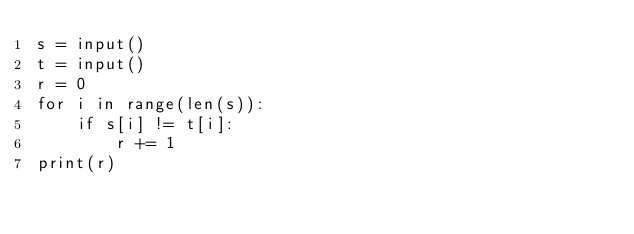<code> <loc_0><loc_0><loc_500><loc_500><_Python_>s = input()
t = input()
r = 0
for i in range(len(s)):
    if s[i] != t[i]:
        r += 1
print(r)</code> 